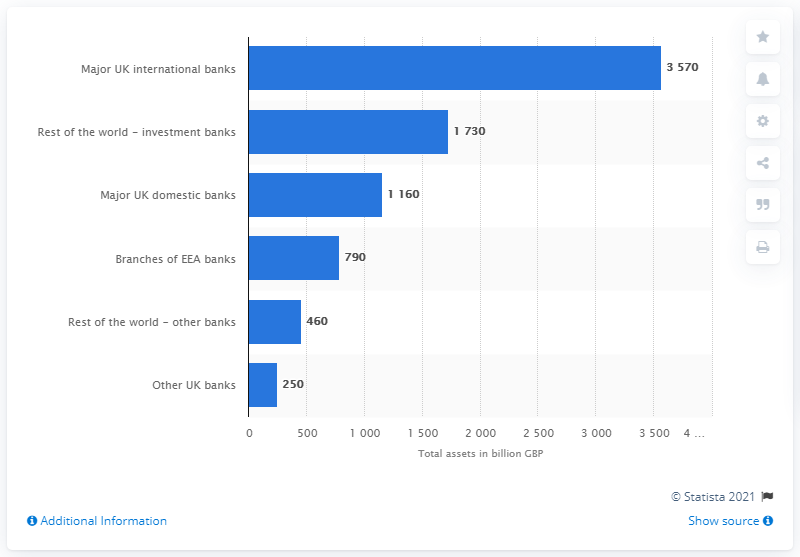Give some essential details in this illustration. As of 2021, the total assets of Barclays, HSBC, Lloyds Banking Group, and The Royal Bank of Scotland Group were valued at approximately 3,570. 